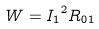Convert formula to latex. <formula><loc_0><loc_0><loc_500><loc_500>W = { I _ { 1 } } ^ { 2 } R _ { 0 1 }</formula> 